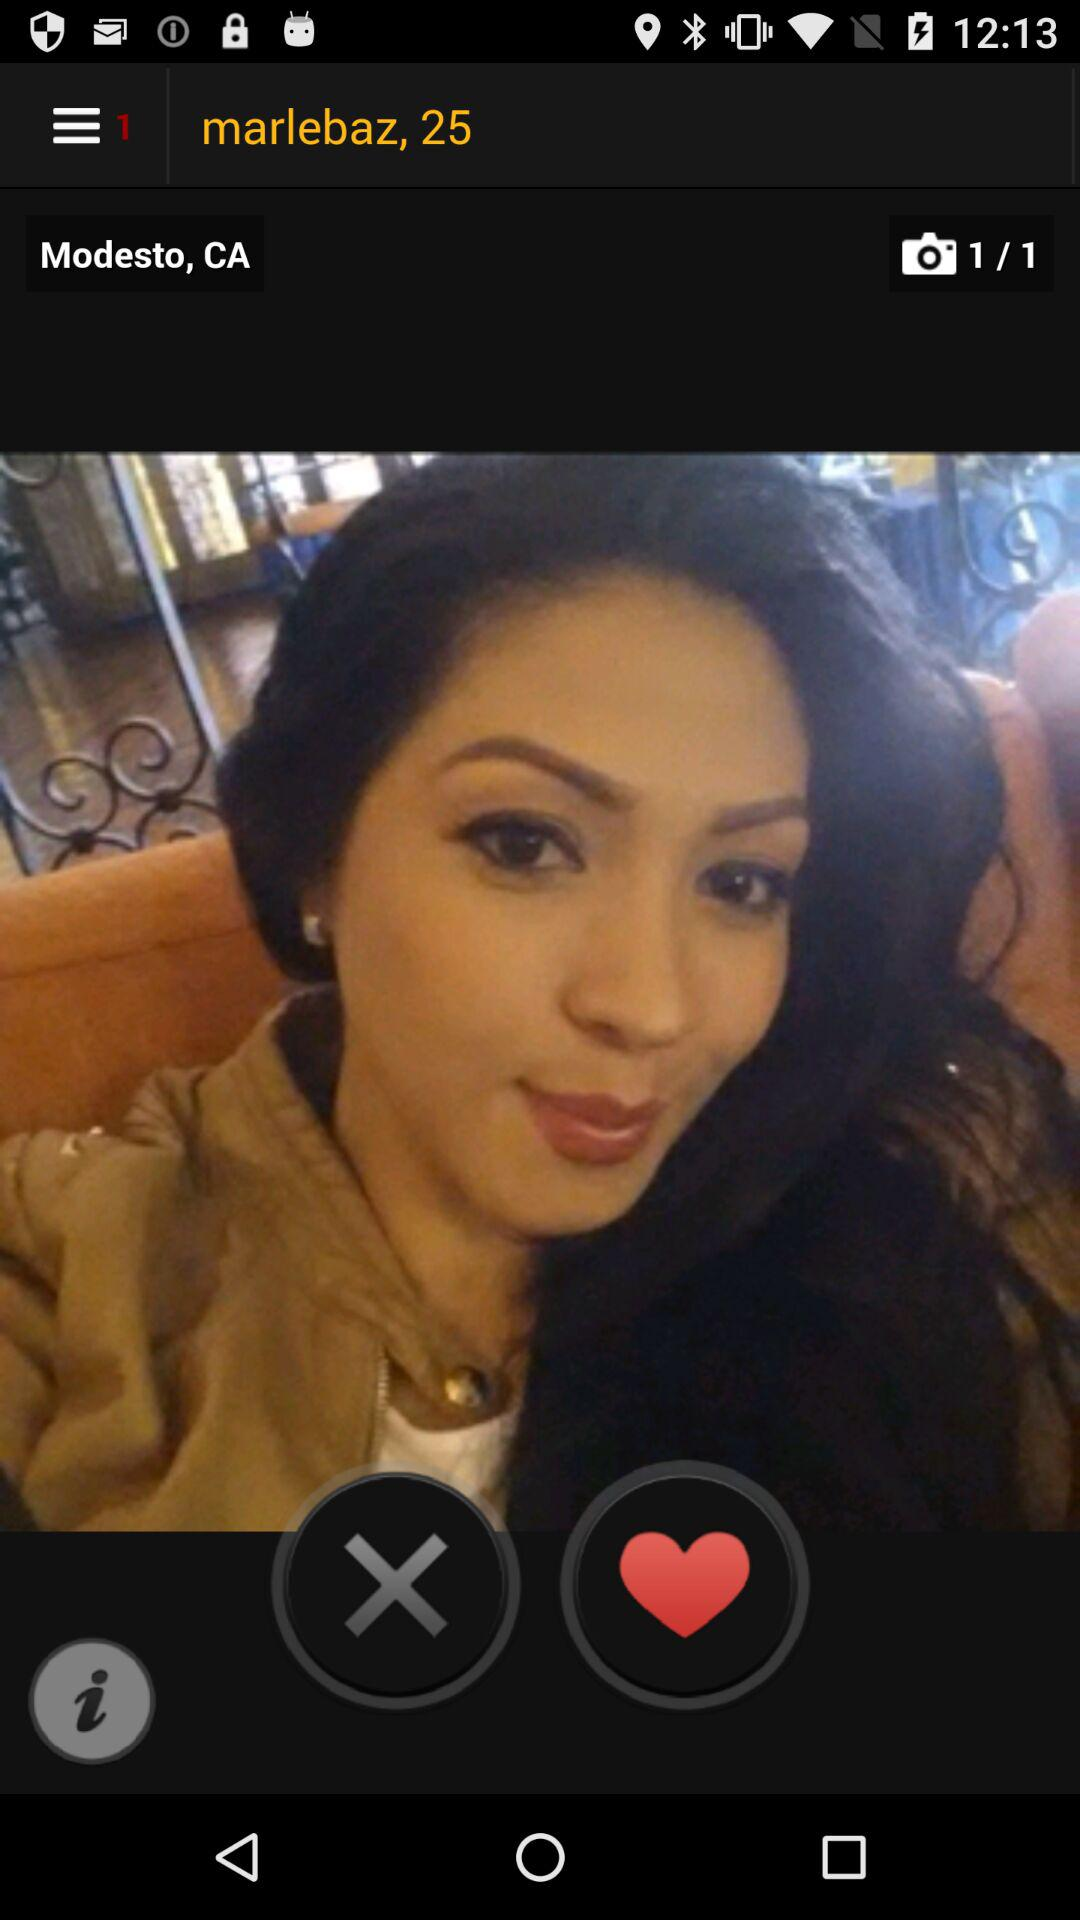What is the age of Marlebaz? Marlebaz is 25 years old. 